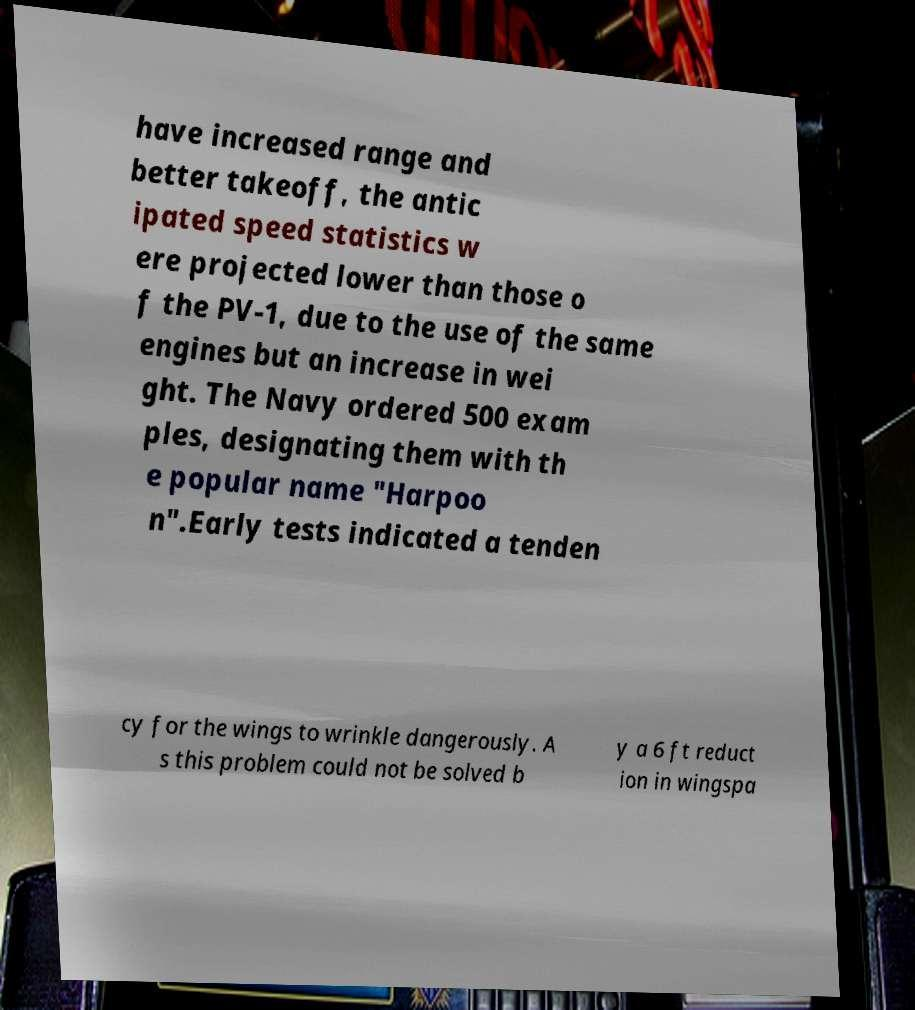Could you assist in decoding the text presented in this image and type it out clearly? have increased range and better takeoff, the antic ipated speed statistics w ere projected lower than those o f the PV-1, due to the use of the same engines but an increase in wei ght. The Navy ordered 500 exam ples, designating them with th e popular name "Harpoo n".Early tests indicated a tenden cy for the wings to wrinkle dangerously. A s this problem could not be solved b y a 6 ft reduct ion in wingspa 